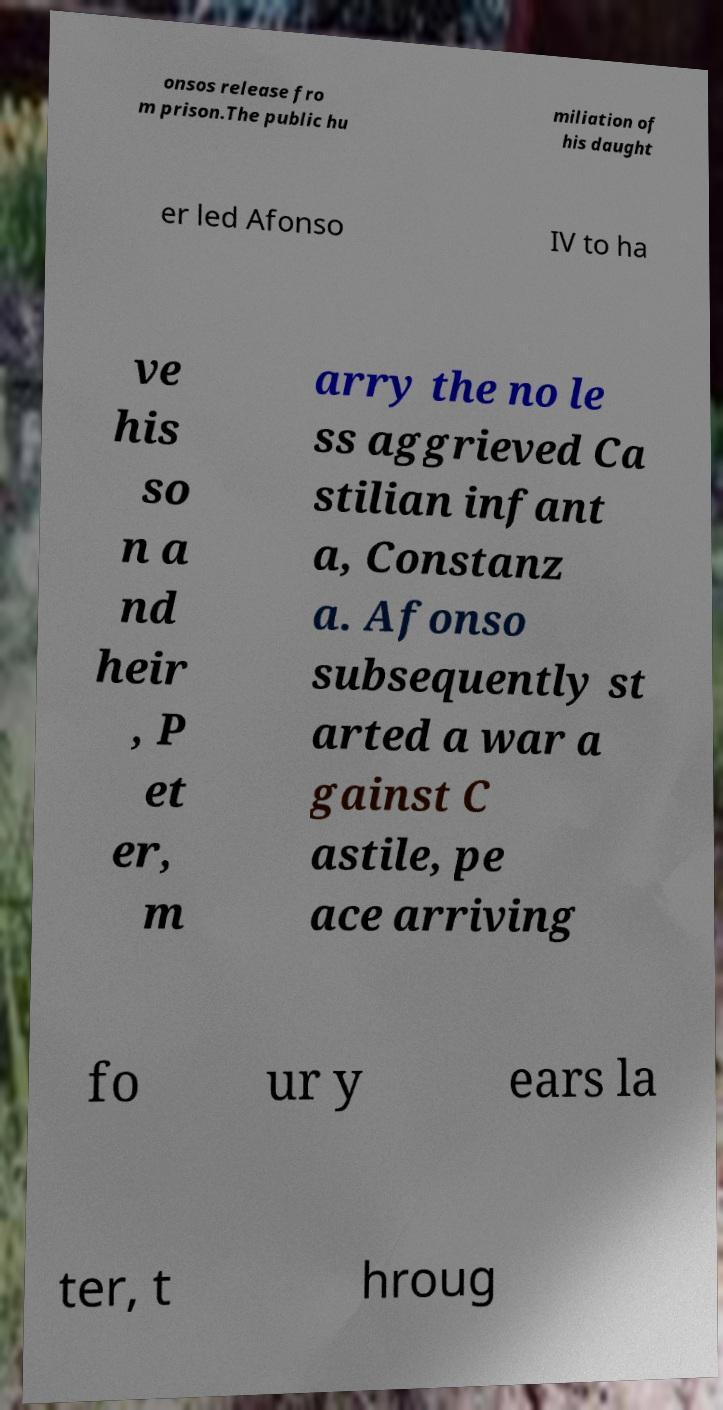Could you extract and type out the text from this image? onsos release fro m prison.The public hu miliation of his daught er led Afonso IV to ha ve his so n a nd heir , P et er, m arry the no le ss aggrieved Ca stilian infant a, Constanz a. Afonso subsequently st arted a war a gainst C astile, pe ace arriving fo ur y ears la ter, t hroug 